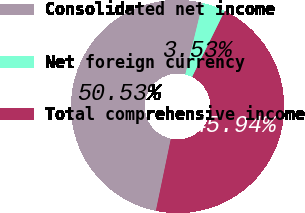Convert chart. <chart><loc_0><loc_0><loc_500><loc_500><pie_chart><fcel>Consolidated net income<fcel>Net foreign currency<fcel>Total comprehensive income<nl><fcel>50.53%<fcel>3.53%<fcel>45.94%<nl></chart> 